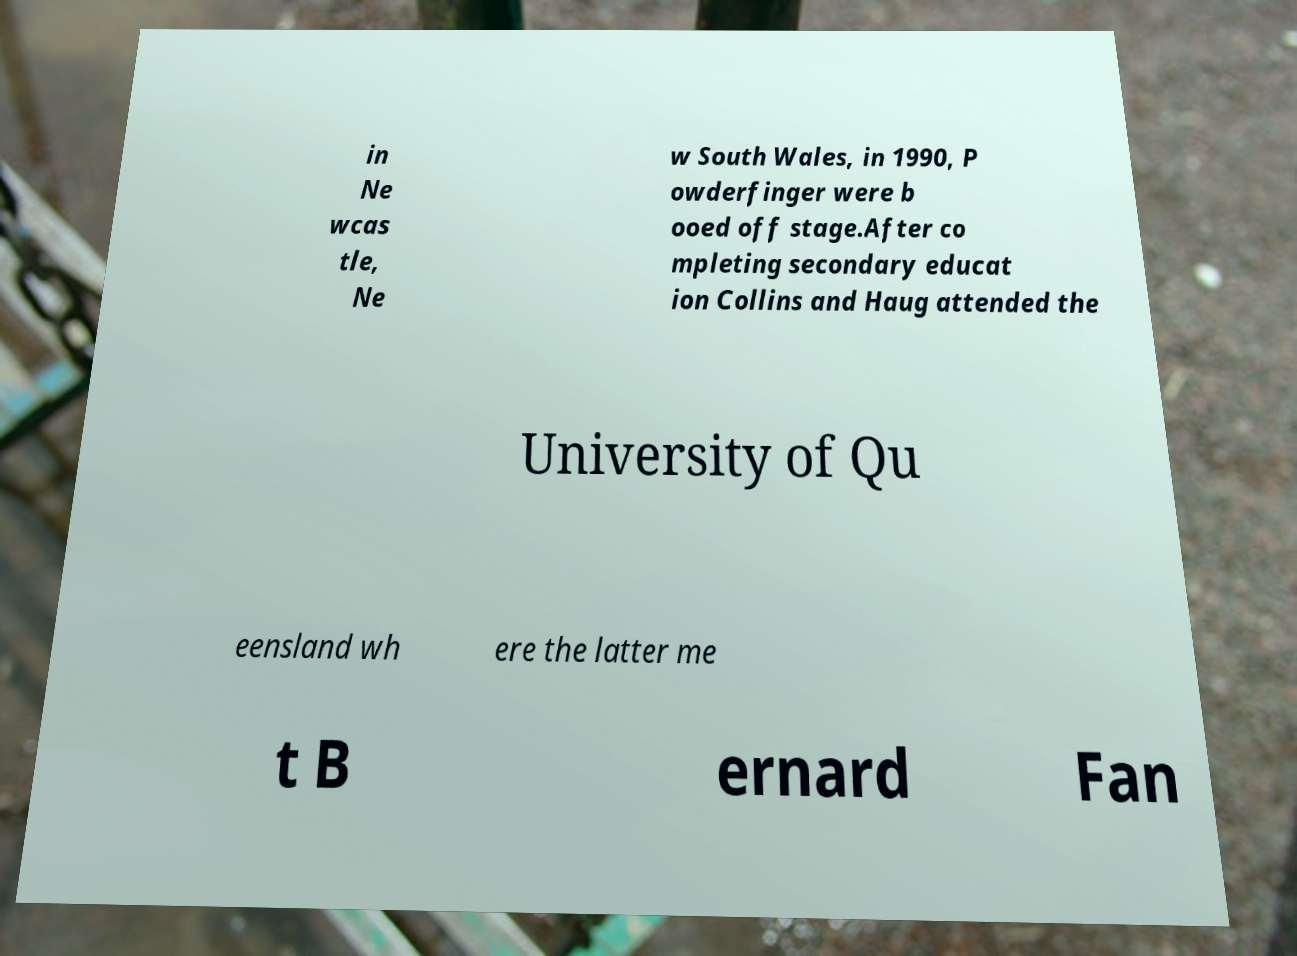Please read and relay the text visible in this image. What does it say? in Ne wcas tle, Ne w South Wales, in 1990, P owderfinger were b ooed off stage.After co mpleting secondary educat ion Collins and Haug attended the University of Qu eensland wh ere the latter me t B ernard Fan 